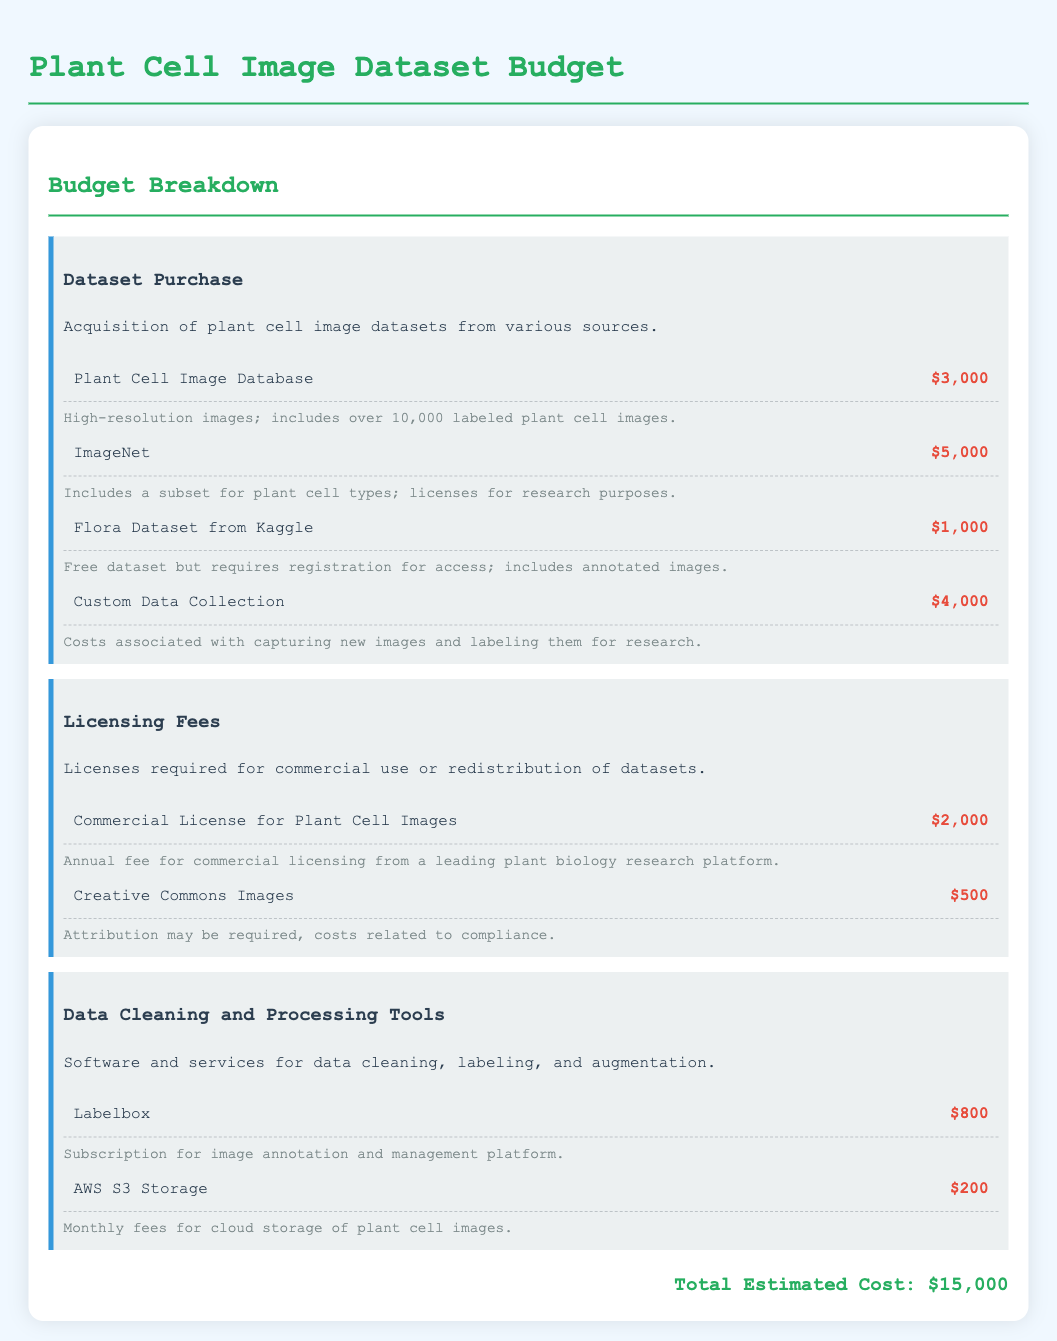What is the total estimated cost? The total estimated cost is presented at the bottom of the document, which sums up all expenses listed.
Answer: $15,000 How much does the Plant Cell Image Database cost? The cost of the Plant Cell Image Database is explicitly mentioned in the dataset purchase section.
Answer: $3,000 What is the annual fee for the commercial license? The annual fee for the commercial license is listed under the licensing fees section of the document.
Answer: $2,000 Which dataset costs $1,000? The specific dataset that costs $1,000 is provided in the purchase section with its corresponding details.
Answer: Flora Dataset from Kaggle What is the purpose of Labelbox? Labelbox's purpose is described in the data cleaning and processing tools category within the document.
Answer: Image annotation and management platform How much is charged per month for AWS S3 Storage? The monthly charge for AWS S3 Storage is found in the data cleaning and processing tools section.
Answer: $200 What type of images does the Creative Commons category include? The Creative Commons category mentions specific licensing information in relation to its image offerings.
Answer: Attribution required images What is the biggest expense in the dataset purchase category? The document specifies the costs associated with various datasets, allowing identification of the largest expense.
Answer: ImageNet 